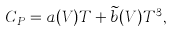Convert formula to latex. <formula><loc_0><loc_0><loc_500><loc_500>C _ { P } = a ( V ) T + \widetilde { b } ( V ) T ^ { 3 } ,</formula> 